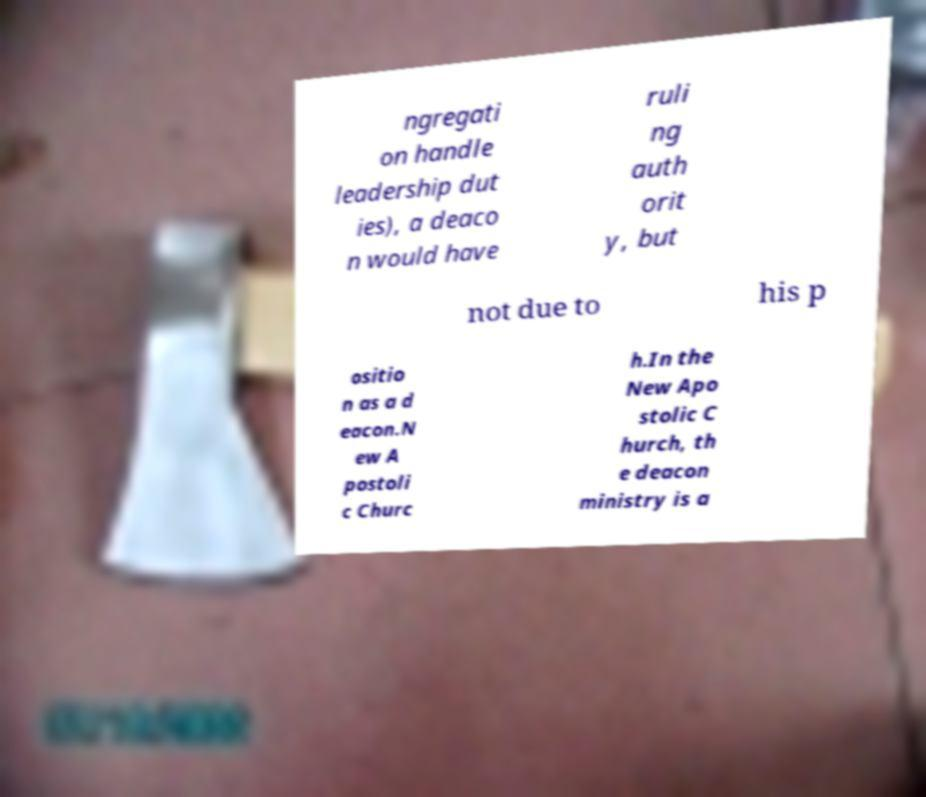Can you accurately transcribe the text from the provided image for me? ngregati on handle leadership dut ies), a deaco n would have ruli ng auth orit y, but not due to his p ositio n as a d eacon.N ew A postoli c Churc h.In the New Apo stolic C hurch, th e deacon ministry is a 